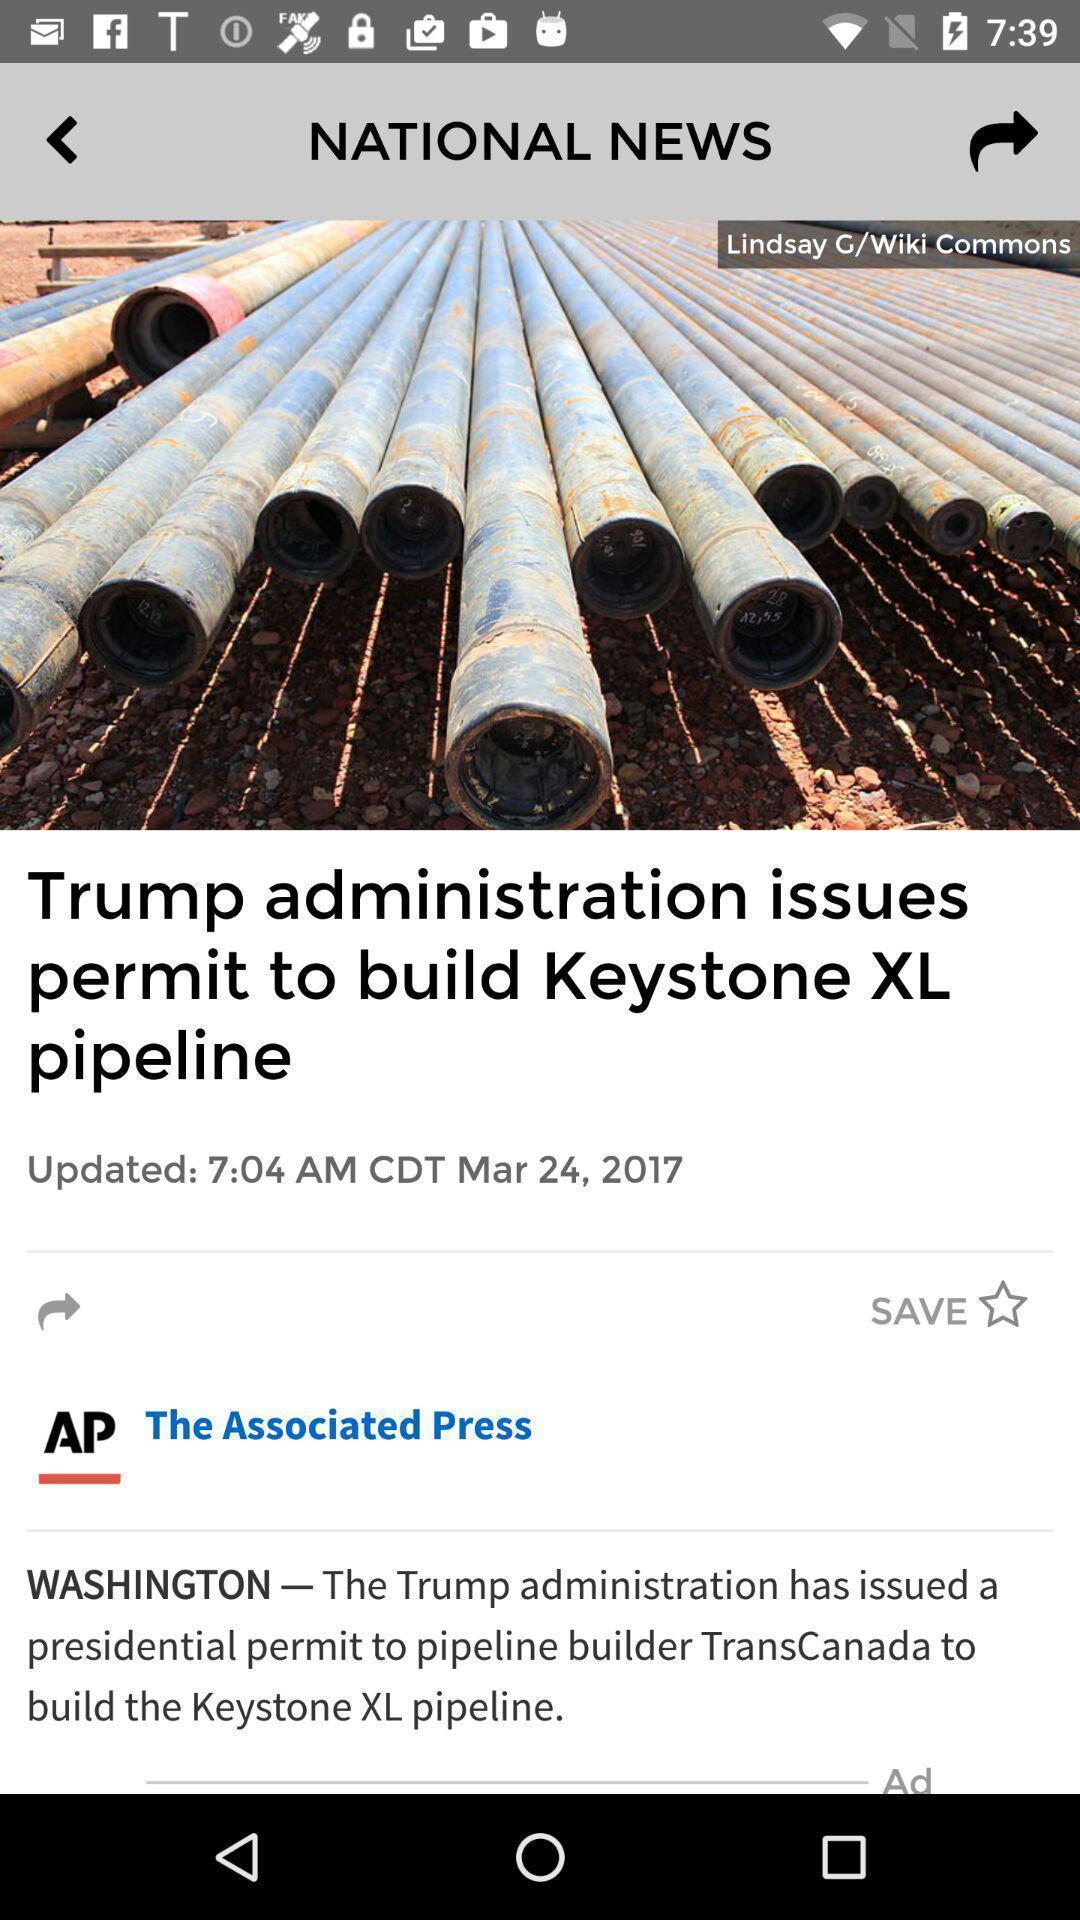Tell me about the visual elements in this screen capture. Screen displaying page of an news application. 